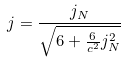<formula> <loc_0><loc_0><loc_500><loc_500>j = \frac { j _ { N } } { \sqrt { 6 + \frac { 6 } { c ^ { 2 } } j _ { N } ^ { 2 } } }</formula> 